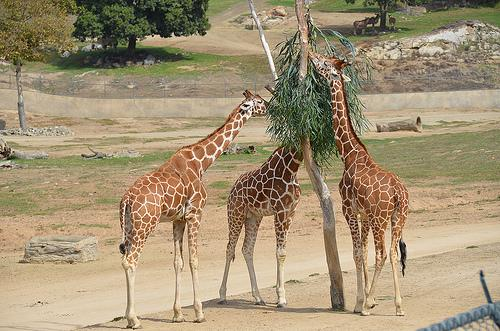Question: what main color are the giraffes?
Choices:
A. White.
B. Yellow.
C. Green.
D. Brown.
Answer with the letter. Answer: D Question: how many giraffes are there?
Choices:
A. One.
B. Two.
C. Four.
D. Three.
Answer with the letter. Answer: D Question: who is standing behind the giraffes?
Choices:
A. No one.
B. A clown.
C. A little girl.
D. A priest.
Answer with the letter. Answer: A 